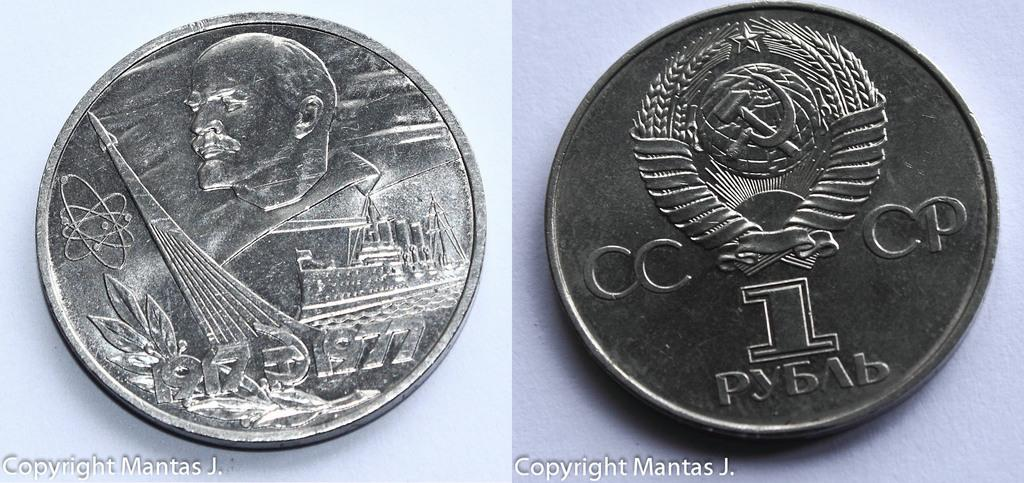<image>
Write a terse but informative summary of the picture. A Russian coin is labeled with the abbreviation CCCP. 